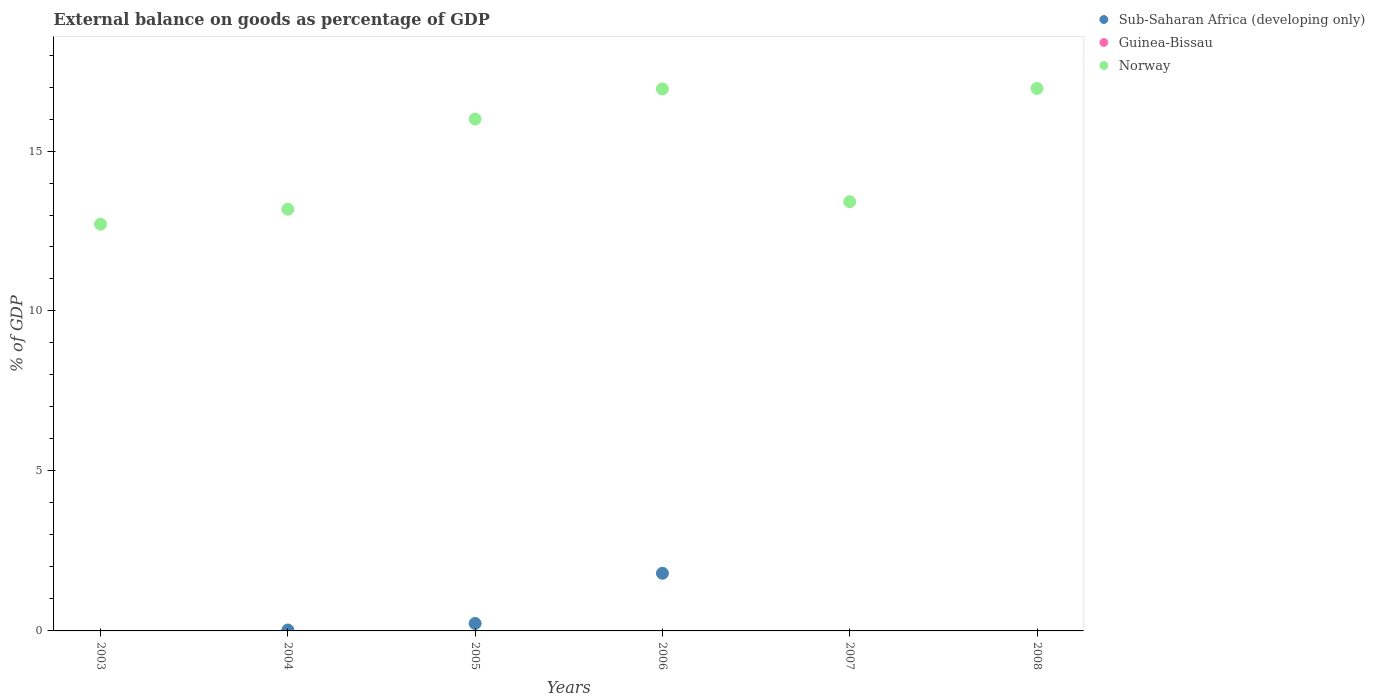Is the number of dotlines equal to the number of legend labels?
Ensure brevity in your answer.  No. Across all years, what is the maximum external balance on goods as percentage of GDP in Sub-Saharan Africa (developing only)?
Offer a terse response. 1.8. What is the total external balance on goods as percentage of GDP in Sub-Saharan Africa (developing only) in the graph?
Provide a short and direct response. 2.06. What is the difference between the external balance on goods as percentage of GDP in Norway in 2004 and that in 2007?
Your answer should be very brief. -0.23. What is the difference between the external balance on goods as percentage of GDP in Sub-Saharan Africa (developing only) in 2006 and the external balance on goods as percentage of GDP in Norway in 2004?
Ensure brevity in your answer.  -11.38. What is the average external balance on goods as percentage of GDP in Guinea-Bissau per year?
Offer a terse response. 0. In the year 2006, what is the difference between the external balance on goods as percentage of GDP in Norway and external balance on goods as percentage of GDP in Sub-Saharan Africa (developing only)?
Offer a very short reply. 15.14. In how many years, is the external balance on goods as percentage of GDP in Guinea-Bissau greater than 15 %?
Offer a terse response. 0. What is the ratio of the external balance on goods as percentage of GDP in Norway in 2003 to that in 2008?
Make the answer very short. 0.75. Is the external balance on goods as percentage of GDP in Norway in 2004 less than that in 2005?
Make the answer very short. Yes. What is the difference between the highest and the second highest external balance on goods as percentage of GDP in Norway?
Keep it short and to the point. 0.01. What is the difference between the highest and the lowest external balance on goods as percentage of GDP in Sub-Saharan Africa (developing only)?
Your answer should be compact. 1.8. In how many years, is the external balance on goods as percentage of GDP in Sub-Saharan Africa (developing only) greater than the average external balance on goods as percentage of GDP in Sub-Saharan Africa (developing only) taken over all years?
Make the answer very short. 1. Is it the case that in every year, the sum of the external balance on goods as percentage of GDP in Norway and external balance on goods as percentage of GDP in Guinea-Bissau  is greater than the external balance on goods as percentage of GDP in Sub-Saharan Africa (developing only)?
Give a very brief answer. Yes. Does the external balance on goods as percentage of GDP in Sub-Saharan Africa (developing only) monotonically increase over the years?
Provide a succinct answer. No. Is the external balance on goods as percentage of GDP in Sub-Saharan Africa (developing only) strictly greater than the external balance on goods as percentage of GDP in Norway over the years?
Your answer should be compact. No. How many years are there in the graph?
Ensure brevity in your answer.  6. What is the difference between two consecutive major ticks on the Y-axis?
Your response must be concise. 5. Does the graph contain grids?
Ensure brevity in your answer.  No. Where does the legend appear in the graph?
Give a very brief answer. Top right. How are the legend labels stacked?
Your response must be concise. Vertical. What is the title of the graph?
Give a very brief answer. External balance on goods as percentage of GDP. What is the label or title of the X-axis?
Ensure brevity in your answer.  Years. What is the label or title of the Y-axis?
Offer a very short reply. % of GDP. What is the % of GDP in Norway in 2003?
Make the answer very short. 12.71. What is the % of GDP of Sub-Saharan Africa (developing only) in 2004?
Ensure brevity in your answer.  0.03. What is the % of GDP of Norway in 2004?
Make the answer very short. 13.18. What is the % of GDP of Sub-Saharan Africa (developing only) in 2005?
Keep it short and to the point. 0.23. What is the % of GDP of Norway in 2005?
Ensure brevity in your answer.  16. What is the % of GDP of Sub-Saharan Africa (developing only) in 2006?
Provide a short and direct response. 1.8. What is the % of GDP in Guinea-Bissau in 2006?
Offer a very short reply. 0. What is the % of GDP in Norway in 2006?
Your response must be concise. 16.94. What is the % of GDP in Sub-Saharan Africa (developing only) in 2007?
Provide a short and direct response. 0. What is the % of GDP of Guinea-Bissau in 2007?
Make the answer very short. 0. What is the % of GDP in Norway in 2007?
Provide a short and direct response. 13.41. What is the % of GDP of Guinea-Bissau in 2008?
Offer a terse response. 0. What is the % of GDP in Norway in 2008?
Keep it short and to the point. 16.96. Across all years, what is the maximum % of GDP of Sub-Saharan Africa (developing only)?
Ensure brevity in your answer.  1.8. Across all years, what is the maximum % of GDP of Norway?
Give a very brief answer. 16.96. Across all years, what is the minimum % of GDP in Norway?
Offer a terse response. 12.71. What is the total % of GDP of Sub-Saharan Africa (developing only) in the graph?
Keep it short and to the point. 2.06. What is the total % of GDP of Norway in the graph?
Provide a succinct answer. 89.2. What is the difference between the % of GDP of Norway in 2003 and that in 2004?
Your answer should be very brief. -0.47. What is the difference between the % of GDP in Norway in 2003 and that in 2005?
Keep it short and to the point. -3.29. What is the difference between the % of GDP of Norway in 2003 and that in 2006?
Provide a succinct answer. -4.23. What is the difference between the % of GDP of Norway in 2003 and that in 2007?
Your response must be concise. -0.7. What is the difference between the % of GDP in Norway in 2003 and that in 2008?
Give a very brief answer. -4.24. What is the difference between the % of GDP of Sub-Saharan Africa (developing only) in 2004 and that in 2005?
Provide a short and direct response. -0.2. What is the difference between the % of GDP of Norway in 2004 and that in 2005?
Keep it short and to the point. -2.82. What is the difference between the % of GDP in Sub-Saharan Africa (developing only) in 2004 and that in 2006?
Make the answer very short. -1.77. What is the difference between the % of GDP in Norway in 2004 and that in 2006?
Keep it short and to the point. -3.76. What is the difference between the % of GDP in Norway in 2004 and that in 2007?
Make the answer very short. -0.23. What is the difference between the % of GDP in Norway in 2004 and that in 2008?
Offer a terse response. -3.77. What is the difference between the % of GDP of Sub-Saharan Africa (developing only) in 2005 and that in 2006?
Offer a very short reply. -1.57. What is the difference between the % of GDP in Norway in 2005 and that in 2006?
Your answer should be compact. -0.94. What is the difference between the % of GDP in Norway in 2005 and that in 2007?
Provide a succinct answer. 2.59. What is the difference between the % of GDP of Norway in 2005 and that in 2008?
Ensure brevity in your answer.  -0.96. What is the difference between the % of GDP in Norway in 2006 and that in 2007?
Offer a terse response. 3.53. What is the difference between the % of GDP of Norway in 2006 and that in 2008?
Give a very brief answer. -0.01. What is the difference between the % of GDP of Norway in 2007 and that in 2008?
Ensure brevity in your answer.  -3.54. What is the difference between the % of GDP in Sub-Saharan Africa (developing only) in 2004 and the % of GDP in Norway in 2005?
Provide a succinct answer. -15.97. What is the difference between the % of GDP in Sub-Saharan Africa (developing only) in 2004 and the % of GDP in Norway in 2006?
Make the answer very short. -16.91. What is the difference between the % of GDP in Sub-Saharan Africa (developing only) in 2004 and the % of GDP in Norway in 2007?
Make the answer very short. -13.39. What is the difference between the % of GDP of Sub-Saharan Africa (developing only) in 2004 and the % of GDP of Norway in 2008?
Provide a short and direct response. -16.93. What is the difference between the % of GDP in Sub-Saharan Africa (developing only) in 2005 and the % of GDP in Norway in 2006?
Provide a succinct answer. -16.71. What is the difference between the % of GDP in Sub-Saharan Africa (developing only) in 2005 and the % of GDP in Norway in 2007?
Provide a short and direct response. -13.18. What is the difference between the % of GDP of Sub-Saharan Africa (developing only) in 2005 and the % of GDP of Norway in 2008?
Offer a terse response. -16.72. What is the difference between the % of GDP of Sub-Saharan Africa (developing only) in 2006 and the % of GDP of Norway in 2007?
Your answer should be compact. -11.61. What is the difference between the % of GDP in Sub-Saharan Africa (developing only) in 2006 and the % of GDP in Norway in 2008?
Keep it short and to the point. -15.15. What is the average % of GDP of Sub-Saharan Africa (developing only) per year?
Offer a terse response. 0.34. What is the average % of GDP of Guinea-Bissau per year?
Your answer should be compact. 0. What is the average % of GDP in Norway per year?
Your response must be concise. 14.87. In the year 2004, what is the difference between the % of GDP in Sub-Saharan Africa (developing only) and % of GDP in Norway?
Provide a succinct answer. -13.15. In the year 2005, what is the difference between the % of GDP in Sub-Saharan Africa (developing only) and % of GDP in Norway?
Provide a succinct answer. -15.77. In the year 2006, what is the difference between the % of GDP of Sub-Saharan Africa (developing only) and % of GDP of Norway?
Your answer should be very brief. -15.14. What is the ratio of the % of GDP in Norway in 2003 to that in 2004?
Provide a succinct answer. 0.96. What is the ratio of the % of GDP in Norway in 2003 to that in 2005?
Make the answer very short. 0.79. What is the ratio of the % of GDP of Norway in 2003 to that in 2006?
Your answer should be very brief. 0.75. What is the ratio of the % of GDP of Norway in 2003 to that in 2007?
Keep it short and to the point. 0.95. What is the ratio of the % of GDP of Norway in 2003 to that in 2008?
Make the answer very short. 0.75. What is the ratio of the % of GDP in Sub-Saharan Africa (developing only) in 2004 to that in 2005?
Keep it short and to the point. 0.12. What is the ratio of the % of GDP of Norway in 2004 to that in 2005?
Keep it short and to the point. 0.82. What is the ratio of the % of GDP in Sub-Saharan Africa (developing only) in 2004 to that in 2006?
Offer a terse response. 0.02. What is the ratio of the % of GDP of Norway in 2004 to that in 2006?
Provide a succinct answer. 0.78. What is the ratio of the % of GDP of Norway in 2004 to that in 2007?
Your answer should be very brief. 0.98. What is the ratio of the % of GDP in Norway in 2004 to that in 2008?
Make the answer very short. 0.78. What is the ratio of the % of GDP of Sub-Saharan Africa (developing only) in 2005 to that in 2006?
Make the answer very short. 0.13. What is the ratio of the % of GDP in Norway in 2005 to that in 2006?
Offer a very short reply. 0.94. What is the ratio of the % of GDP of Norway in 2005 to that in 2007?
Ensure brevity in your answer.  1.19. What is the ratio of the % of GDP in Norway in 2005 to that in 2008?
Provide a succinct answer. 0.94. What is the ratio of the % of GDP of Norway in 2006 to that in 2007?
Offer a very short reply. 1.26. What is the ratio of the % of GDP in Norway in 2007 to that in 2008?
Your answer should be very brief. 0.79. What is the difference between the highest and the second highest % of GDP in Sub-Saharan Africa (developing only)?
Give a very brief answer. 1.57. What is the difference between the highest and the second highest % of GDP of Norway?
Offer a very short reply. 0.01. What is the difference between the highest and the lowest % of GDP in Sub-Saharan Africa (developing only)?
Your answer should be compact. 1.8. What is the difference between the highest and the lowest % of GDP of Norway?
Provide a succinct answer. 4.24. 